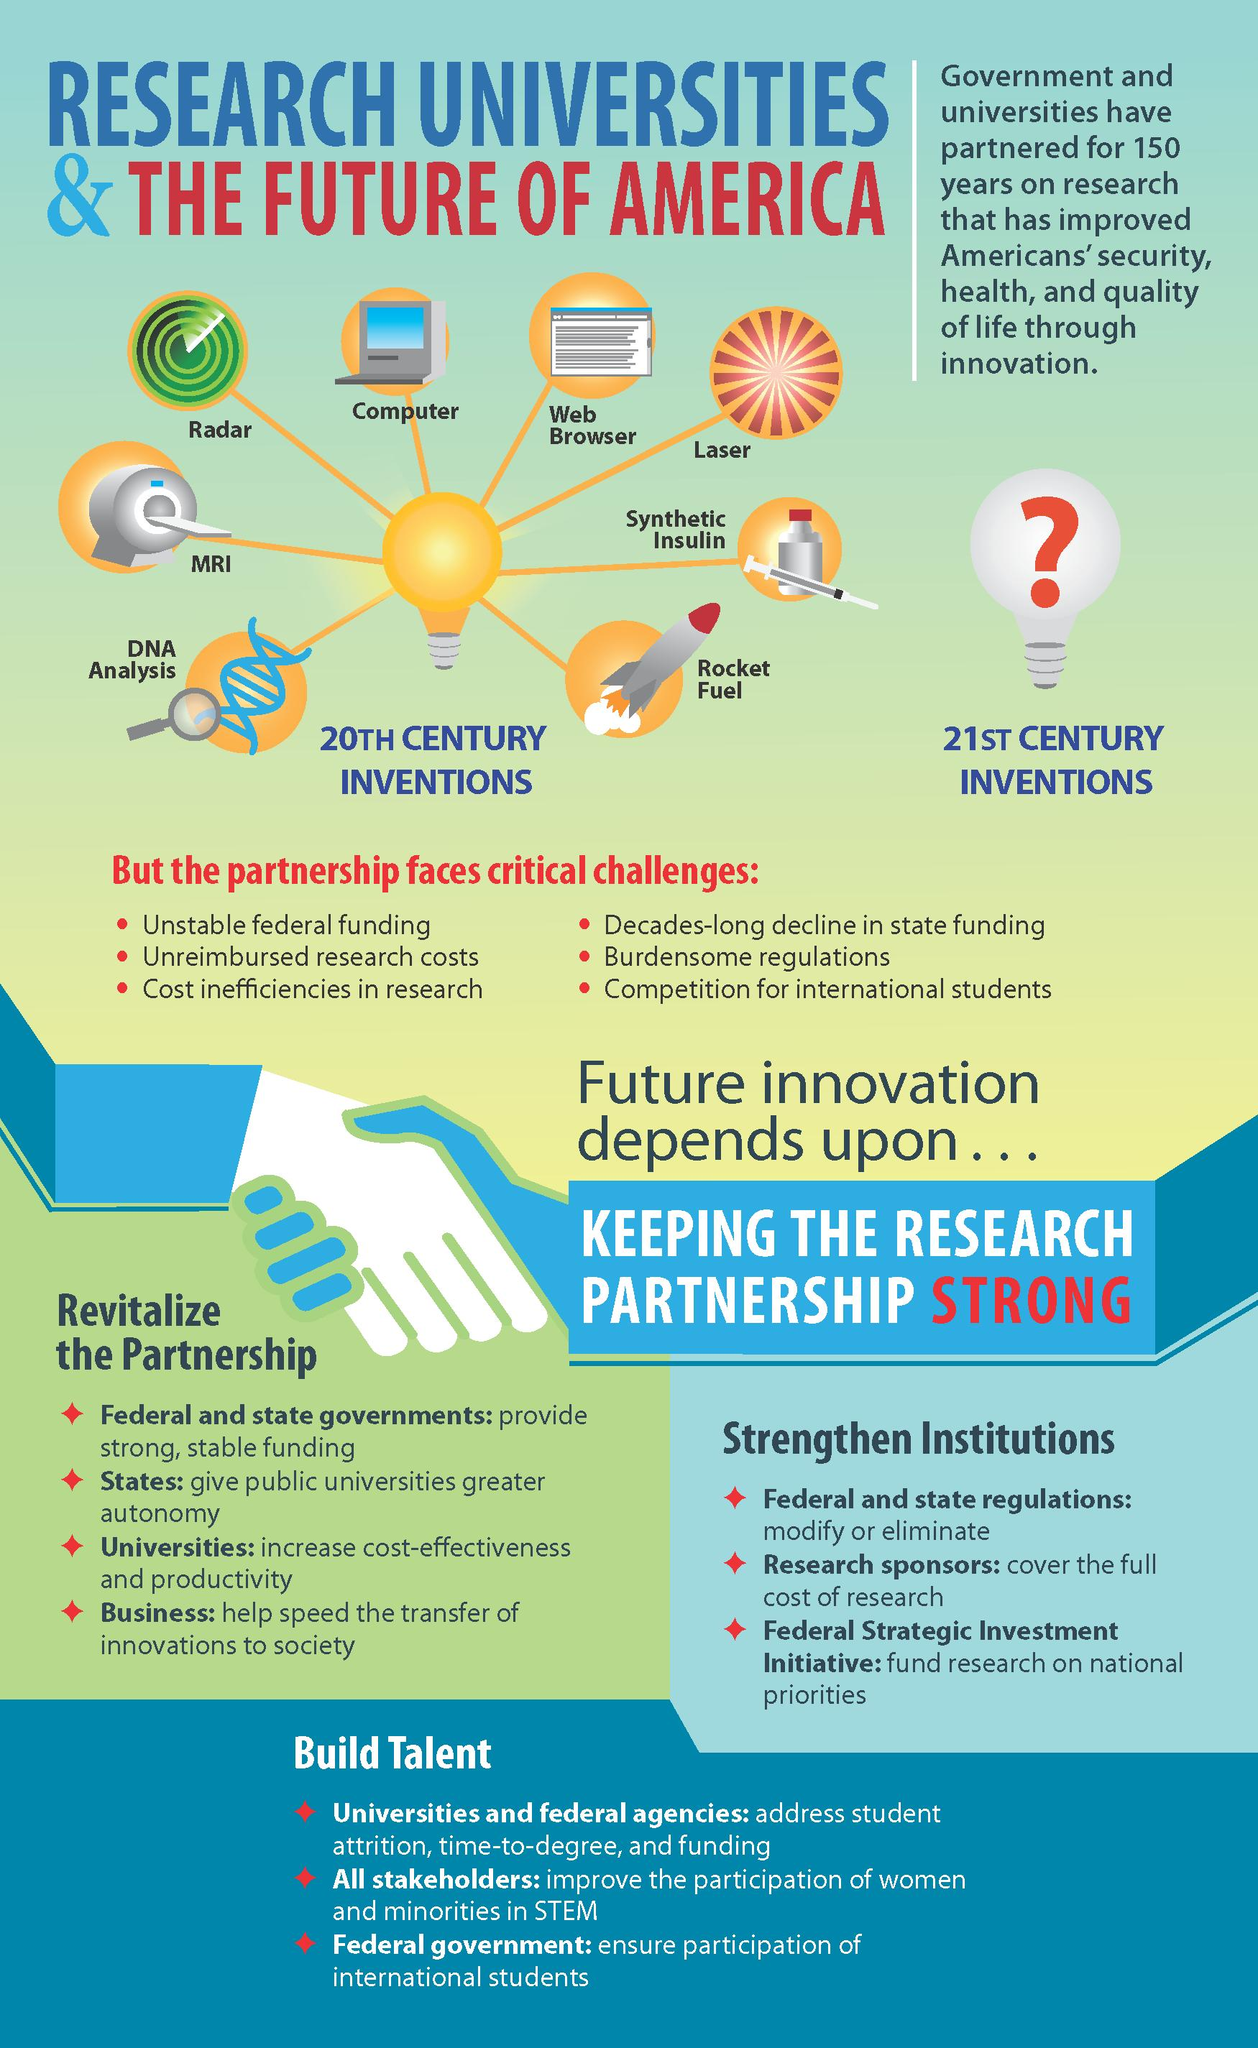Draw attention to some important aspects in this diagram. In the 20th century, a significant number of inventions were made, with 8 of them being identified. 